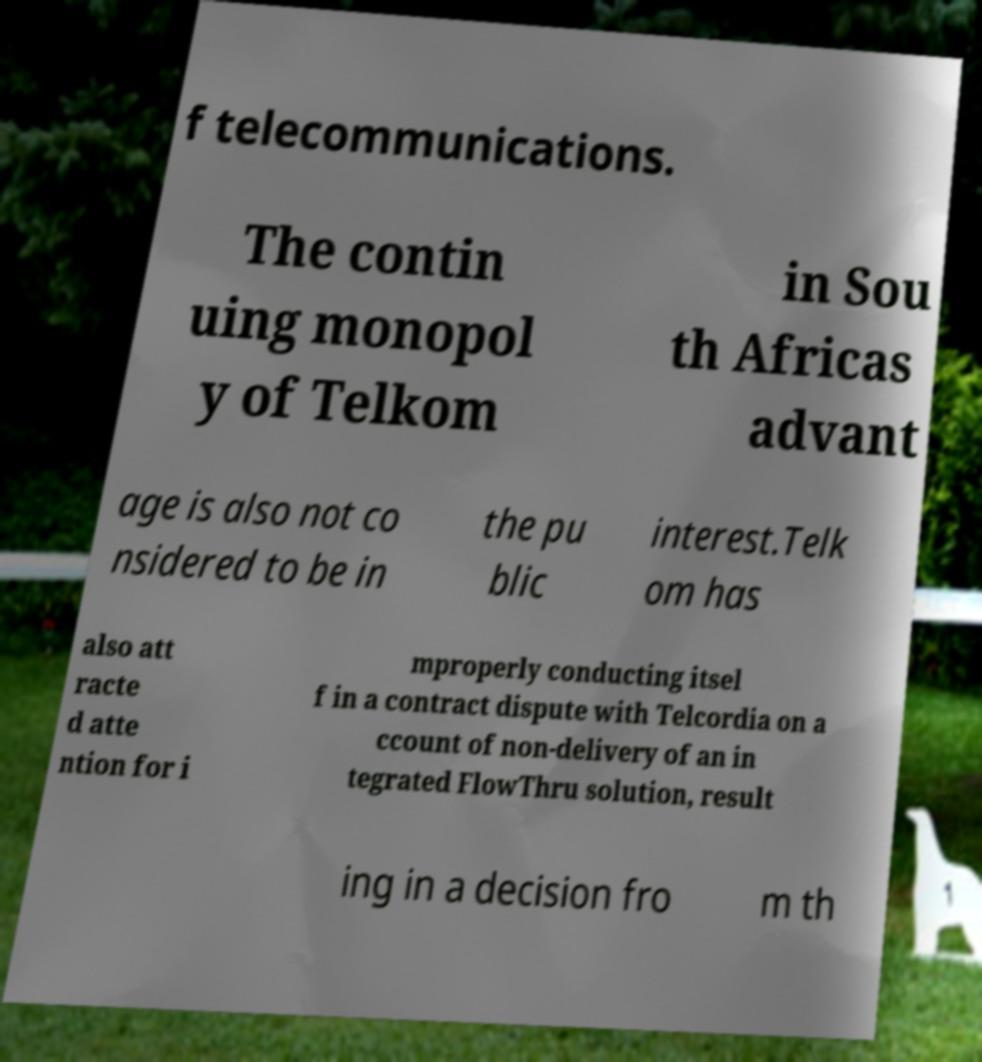Please identify and transcribe the text found in this image. f telecommunications. The contin uing monopol y of Telkom in Sou th Africas advant age is also not co nsidered to be in the pu blic interest.Telk om has also att racte d atte ntion for i mproperly conducting itsel f in a contract dispute with Telcordia on a ccount of non-delivery of an in tegrated FlowThru solution, result ing in a decision fro m th 